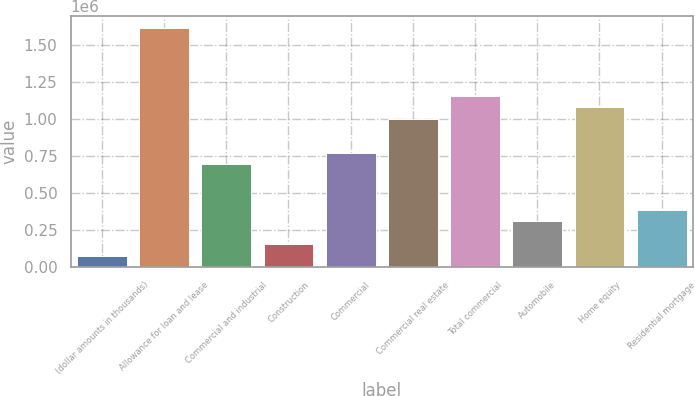<chart> <loc_0><loc_0><loc_500><loc_500><bar_chart><fcel>(dollar amounts in thousands)<fcel>Allowance for loan and lease<fcel>Commercial and industrial<fcel>Construction<fcel>Commercial<fcel>Commercial real estate<fcel>Total commercial<fcel>Automobile<fcel>Home equity<fcel>Residential mortgage<nl><fcel>77209.9<fcel>1.61469e+06<fcel>692201<fcel>154084<fcel>769075<fcel>999697<fcel>1.15344e+06<fcel>307832<fcel>1.07657e+06<fcel>384706<nl></chart> 